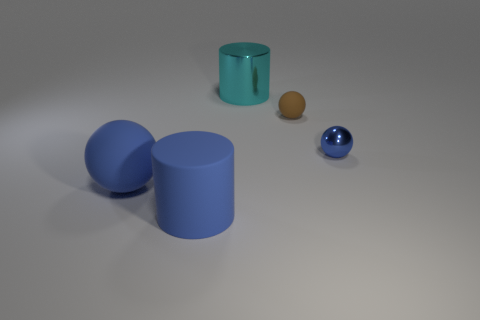Subtract 1 balls. How many balls are left? 2 Add 1 brown matte objects. How many objects exist? 6 Subtract all balls. How many objects are left? 2 Add 5 tiny brown rubber spheres. How many tiny brown rubber spheres are left? 6 Add 1 tiny brown things. How many tiny brown things exist? 2 Subtract 0 red blocks. How many objects are left? 5 Subtract all brown balls. Subtract all metal spheres. How many objects are left? 3 